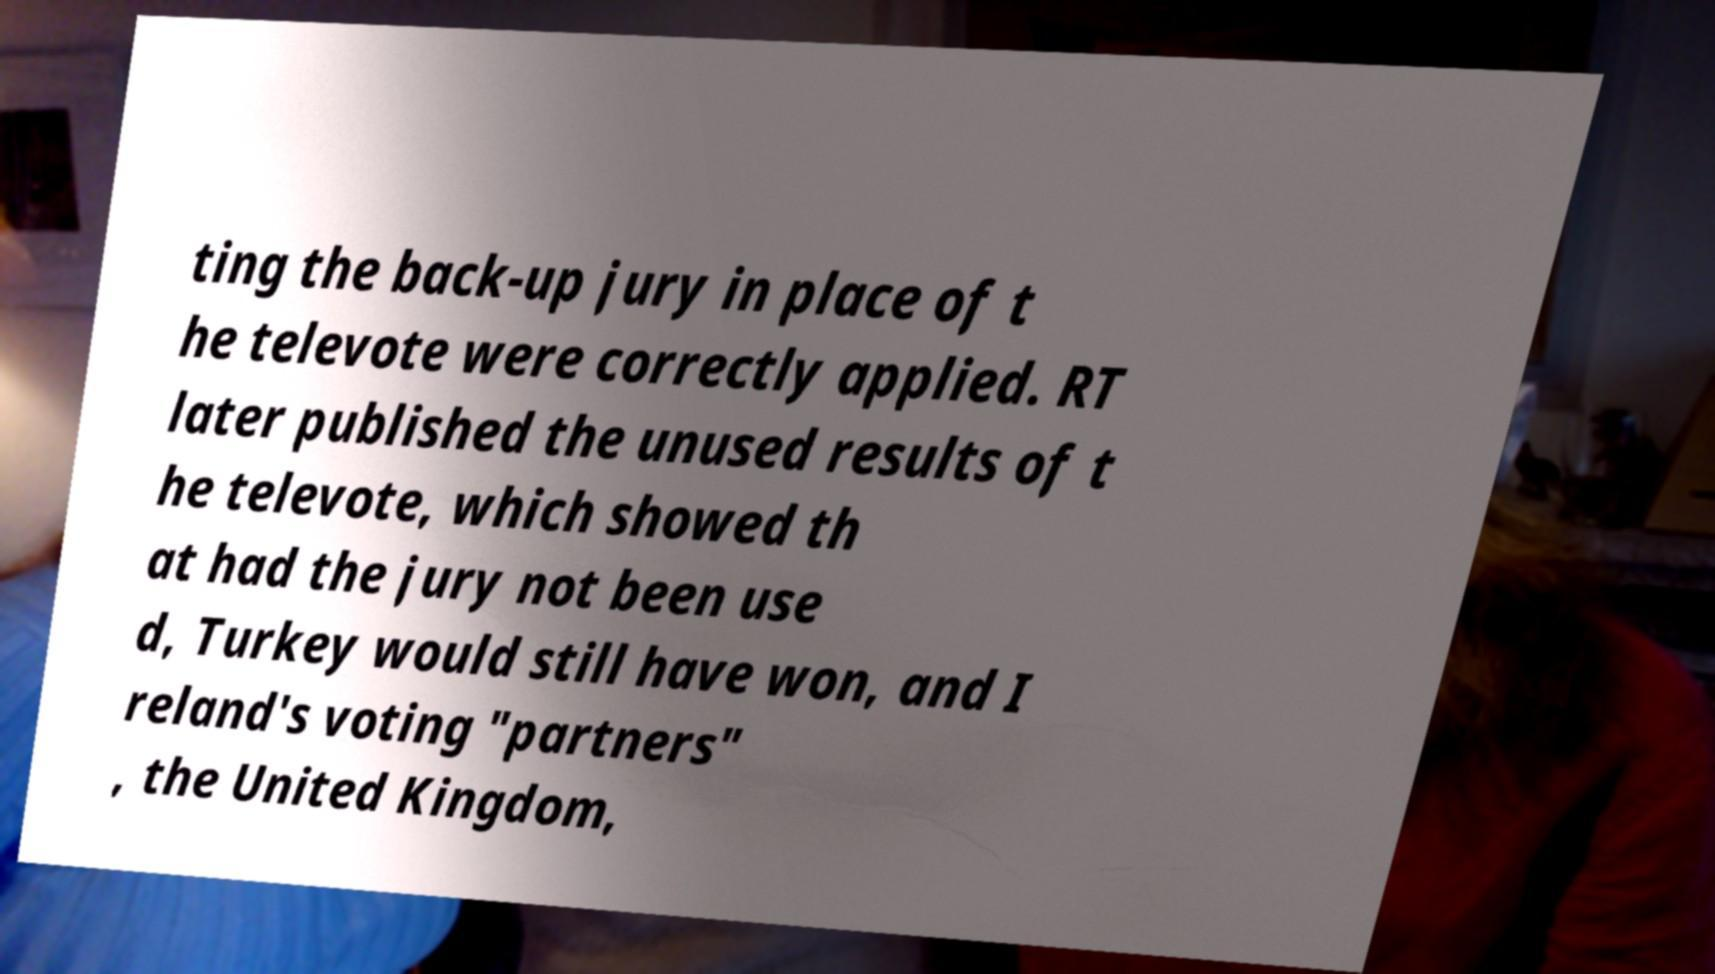There's text embedded in this image that I need extracted. Can you transcribe it verbatim? ting the back-up jury in place of t he televote were correctly applied. RT later published the unused results of t he televote, which showed th at had the jury not been use d, Turkey would still have won, and I reland's voting "partners" , the United Kingdom, 